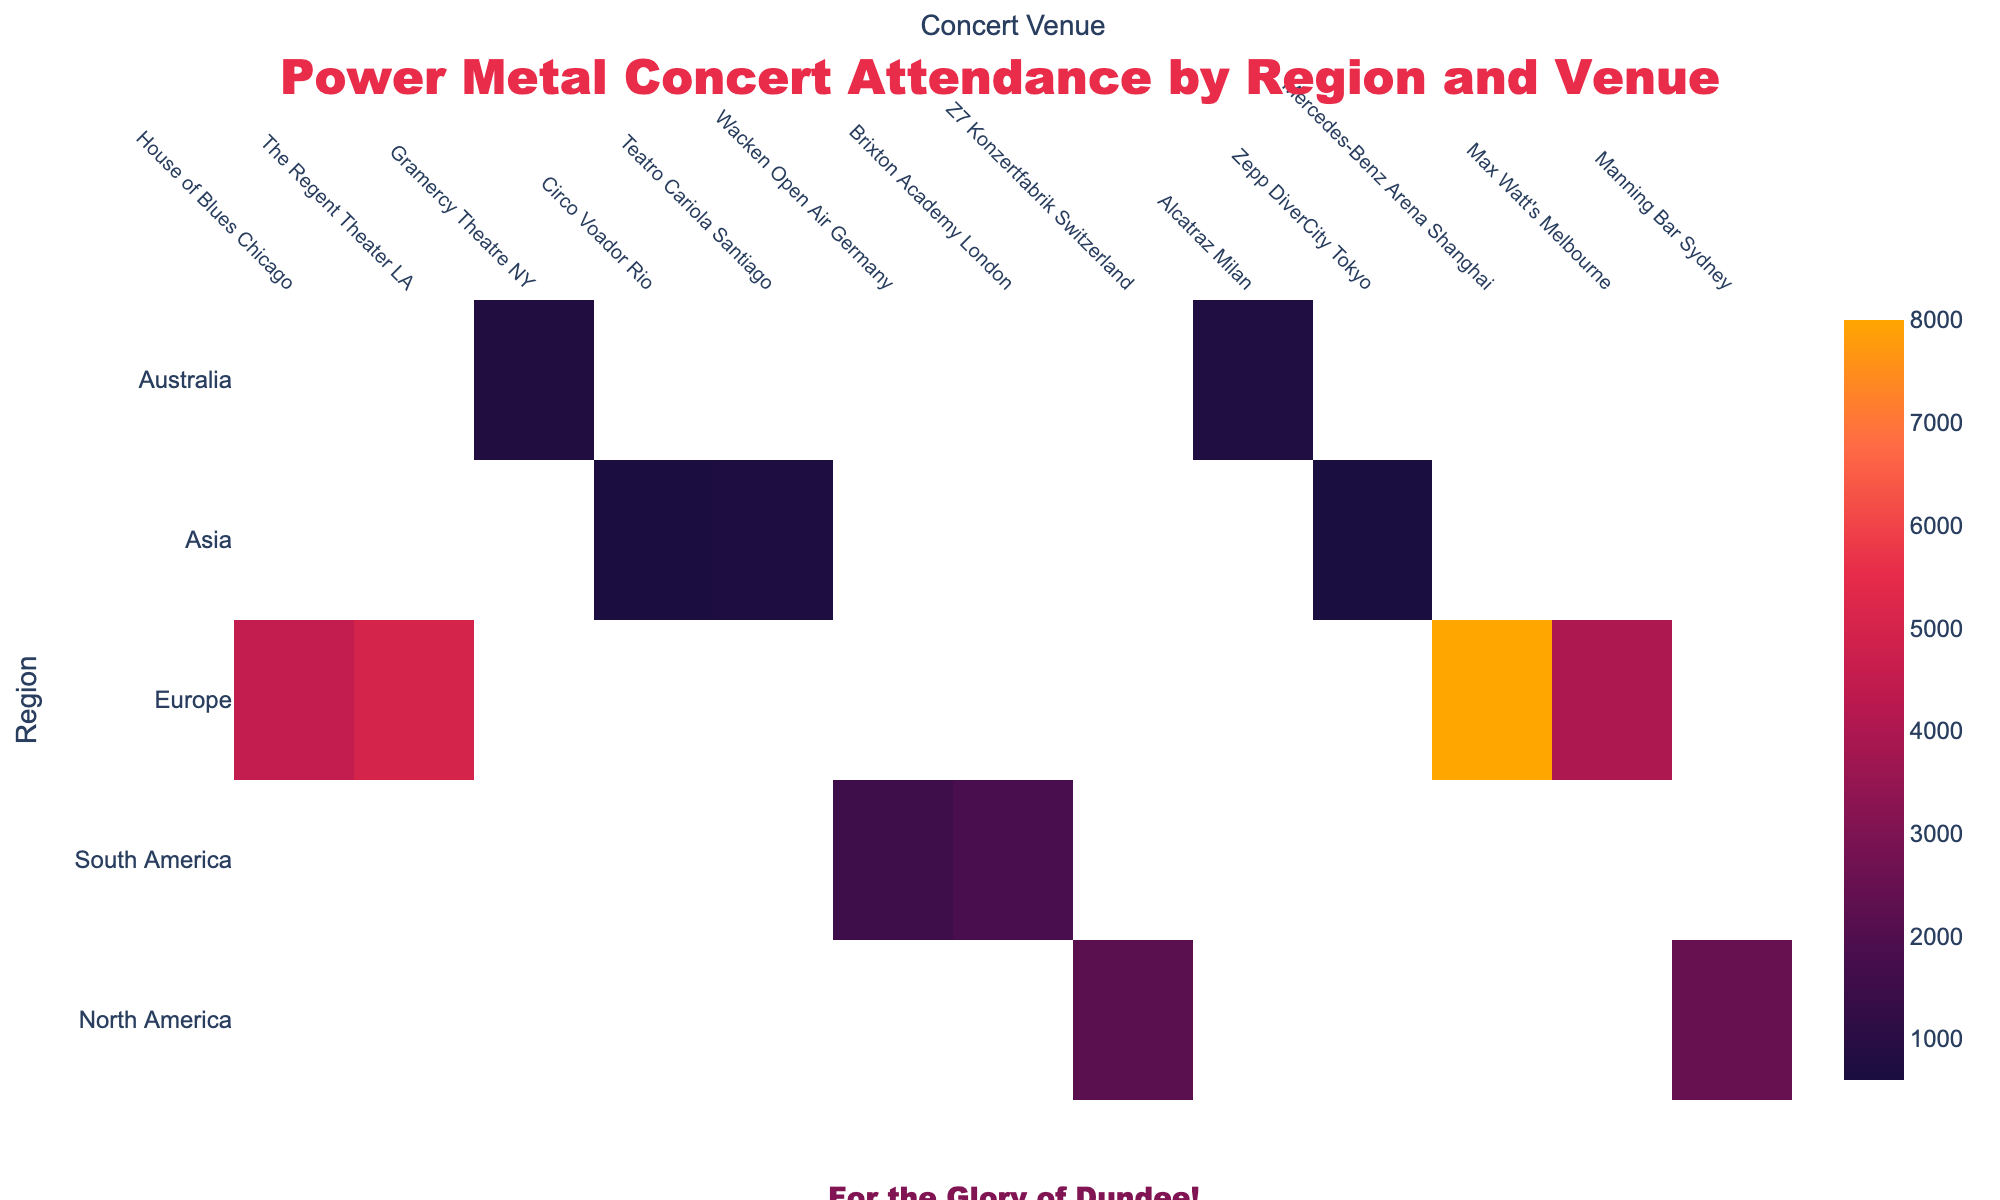What's the highest average attendance across all venues? To find the highest average attendance, look at the values in the heatmap and identify the largest number. The highest average attendance is at 'Wacken Open Air Germany' with a value of 8000.
Answer: 8000 Which regions hold the most concerts, based on the number of venues listed in each region? Count the number of venues listed under each region. Europe has 4 venues, North America has 3, South America has 2, Asia has 2, and Australia has 2. Hence, Europe holds the most concerts based on the number of venues.
Answer: Europe Comparing 'House of Blues Chicago' and 'Teatro Cariola Santiago', which venue has higher average attendance? Compare the average attendance values for 'House of Blues Chicago' (700) and 'Teatro Cariola Santiago' (750). 'Teatro Cariola Santiago' has the higher average attendance.
Answer: Teatro Cariola Santiago On average, which region has the lowest attendance figures? Look at the values for each region and visually estimate which region has the smallest average values. Based on the values: Australia has 1800 and 1500, making the average attendance approximately (1800 + 1500) / 2 = 1650. Australia has the lowest average attendance.
Answer: Australia Which venue in Asia has the highest average attendance? Compare the average attendance values for the two Asian venues: 'Zepp DiverCity Tokyo' (2500) and 'Mercedes-Benz Arena Shanghai' (2200). 'Zepp DiverCity Tokyo' has the higher average attendance.
Answer: Zepp DiverCity Tokyo What is the average attendance for venues in North America? Sum the average attendance values for the three North American venues: 700 + 600 + 650 = 1950. Divide by 3 to get the average: 1950 / 3 = 650.
Answer: 650 Which venue has the lowest average attendance, and what region is it in? Identify the smallest value among all venues. 'Manning Bar Sydney' with an attendance figure of 1500 has the lowest, and it is in Australia.
Answer: Manning Bar Sydney, Australia Do any venues in Europe have an average attendance less than 5000? Check if any values for European venues are less than 5000. 'Z7 Konzertfabrik Switzerland' (4000) and 'Alcatraz Milan' (4500) both have values below 5000.
Answer: Yes How many venues have an average attendance greater than 5000? Count the number of values across all regions that are greater than 5000. 'Wacken Open Air Germany' (8000), 'Brixton Academy London' (5000), and 'Teatro Cariola Santiago' (750) have values greater than 5000. Therefore, there are 3 such venues.
Answer: 3 